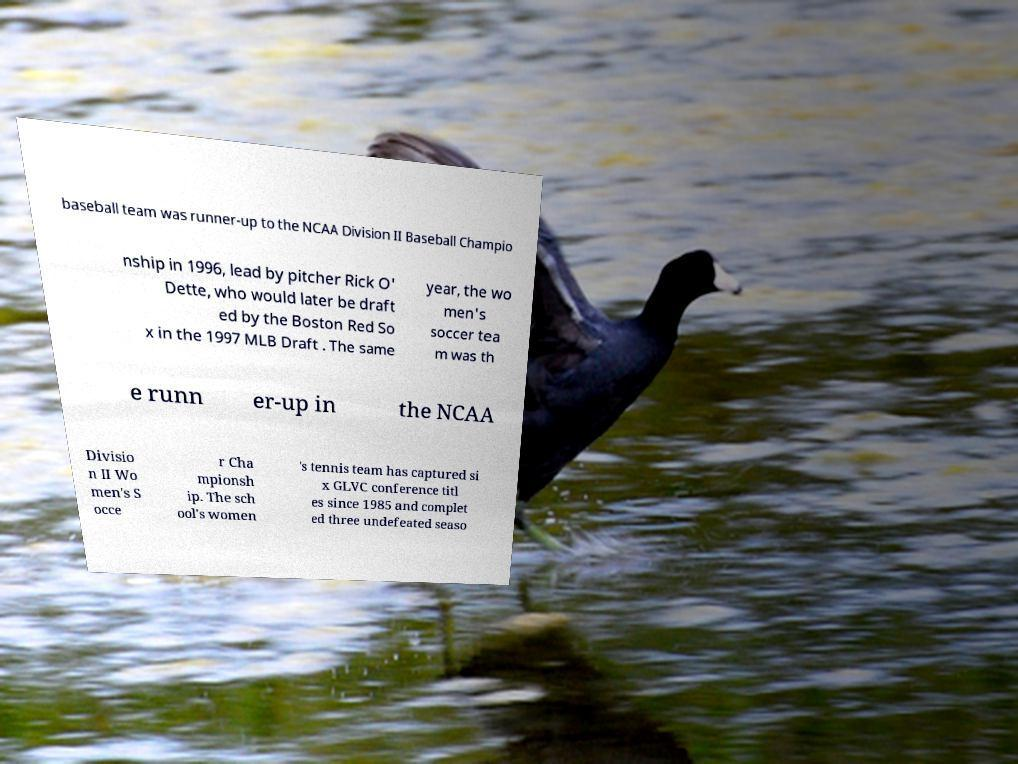I need the written content from this picture converted into text. Can you do that? baseball team was runner-up to the NCAA Division II Baseball Champio nship in 1996, lead by pitcher Rick O' Dette, who would later be draft ed by the Boston Red So x in the 1997 MLB Draft . The same year, the wo men's soccer tea m was th e runn er-up in the NCAA Divisio n II Wo men's S occe r Cha mpionsh ip. The sch ool's women 's tennis team has captured si x GLVC conference titl es since 1985 and complet ed three undefeated seaso 